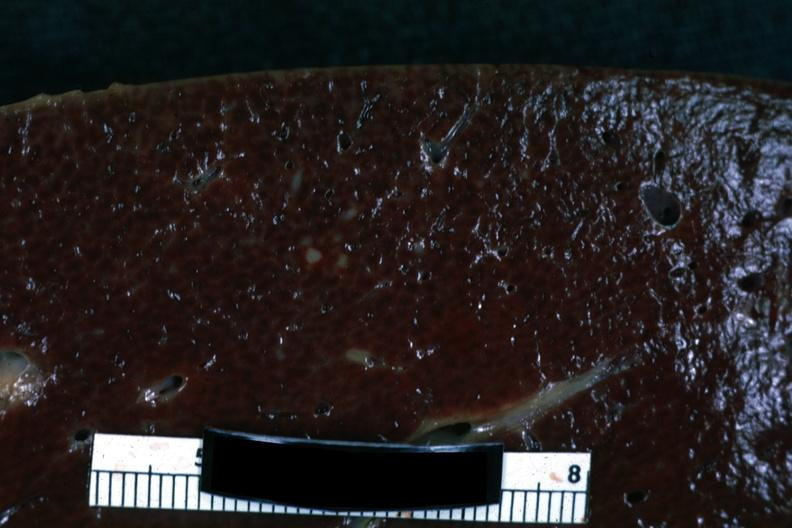s potters facies present?
Answer the question using a single word or phrase. No 